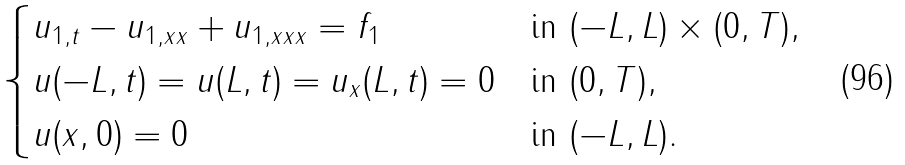<formula> <loc_0><loc_0><loc_500><loc_500>\begin{cases} u _ { 1 , t } - u _ { 1 , x x } + u _ { 1 , x x x } = f _ { 1 } & \text {in $ (-L,L) \times (0,T),$} \\ u ( - L , t ) = u ( L , t ) = u _ { x } ( L , t ) = 0 & \text {in $(0,T),$} \\ u ( x , 0 ) = 0 & \text {in $(-L,L)$} . \end{cases}</formula> 